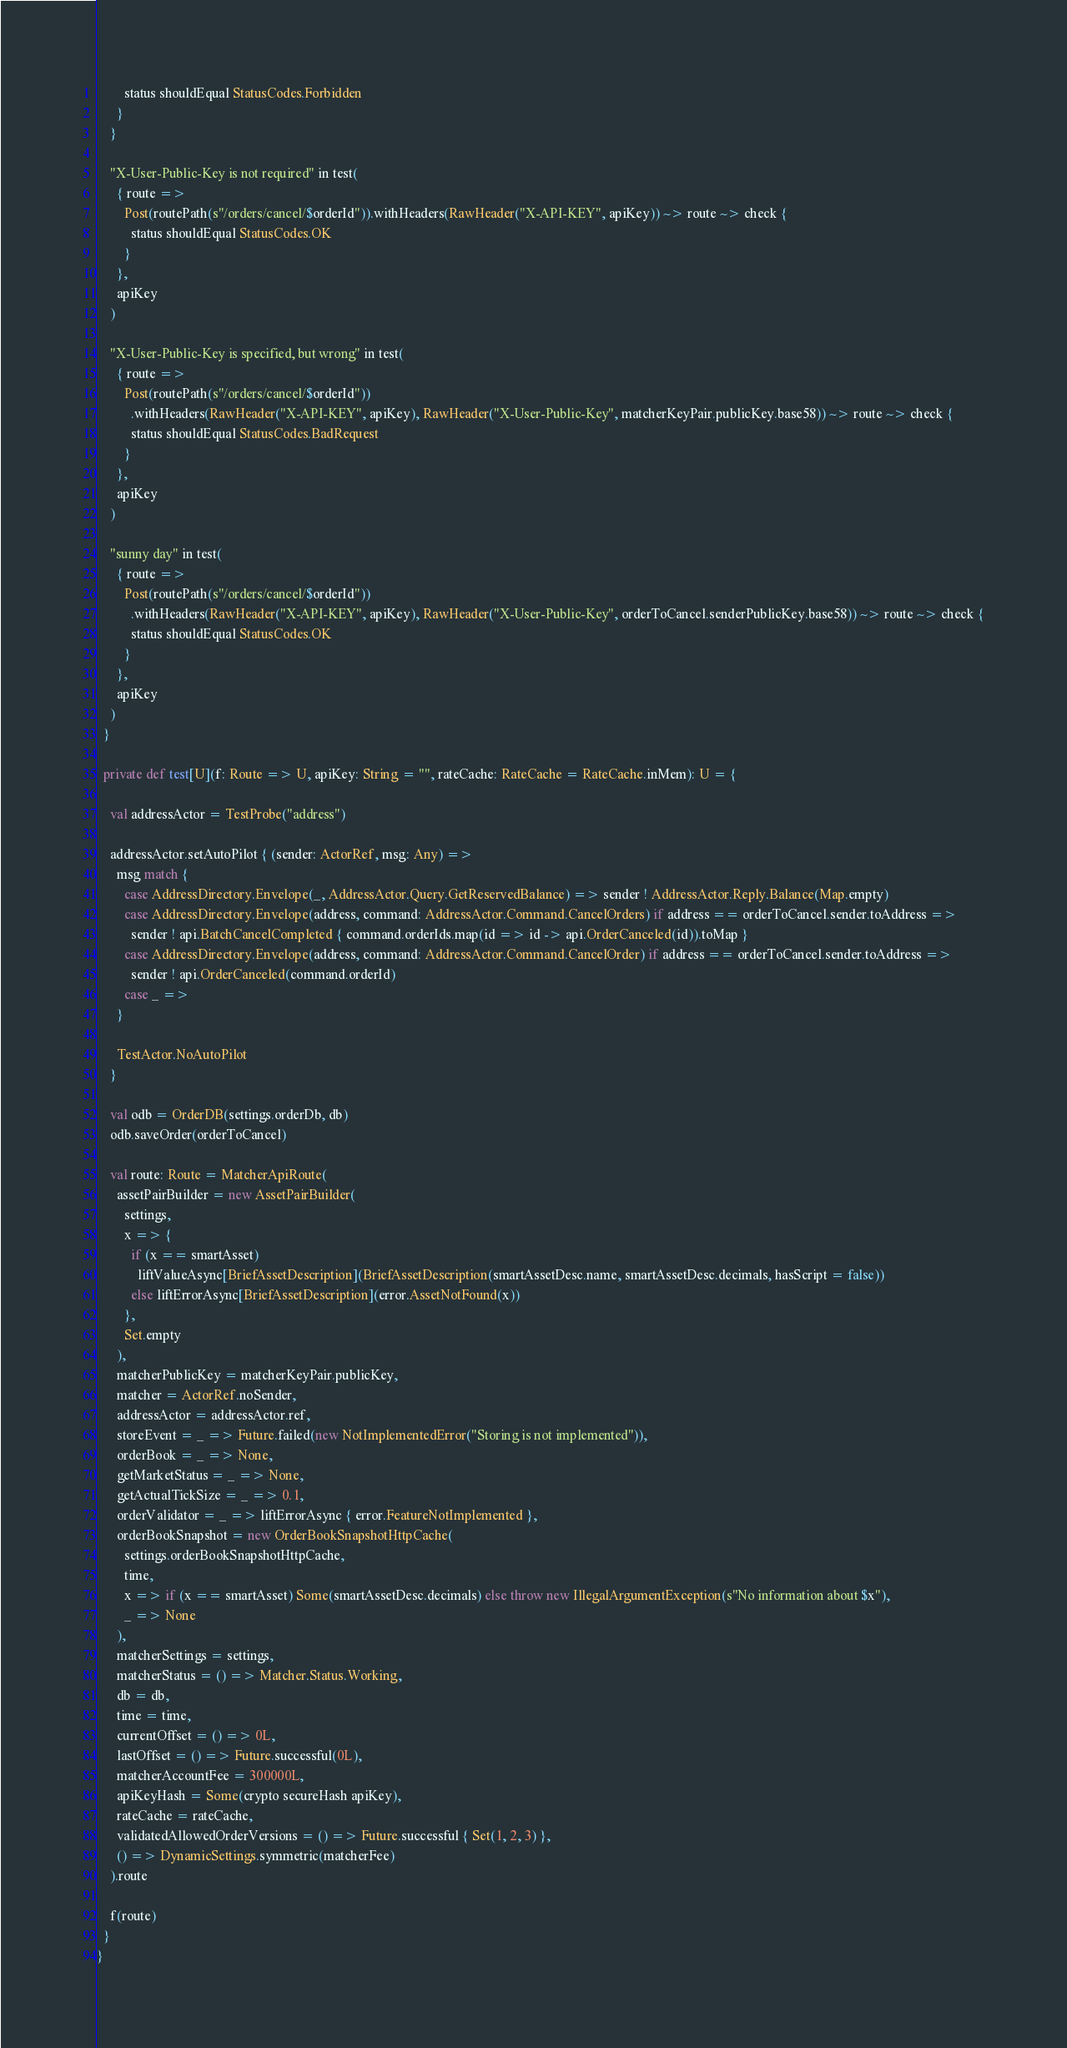Convert code to text. <code><loc_0><loc_0><loc_500><loc_500><_Scala_>        status shouldEqual StatusCodes.Forbidden
      }
    }

    "X-User-Public-Key is not required" in test(
      { route =>
        Post(routePath(s"/orders/cancel/$orderId")).withHeaders(RawHeader("X-API-KEY", apiKey)) ~> route ~> check {
          status shouldEqual StatusCodes.OK
        }
      },
      apiKey
    )

    "X-User-Public-Key is specified, but wrong" in test(
      { route =>
        Post(routePath(s"/orders/cancel/$orderId"))
          .withHeaders(RawHeader("X-API-KEY", apiKey), RawHeader("X-User-Public-Key", matcherKeyPair.publicKey.base58)) ~> route ~> check {
          status shouldEqual StatusCodes.BadRequest
        }
      },
      apiKey
    )

    "sunny day" in test(
      { route =>
        Post(routePath(s"/orders/cancel/$orderId"))
          .withHeaders(RawHeader("X-API-KEY", apiKey), RawHeader("X-User-Public-Key", orderToCancel.senderPublicKey.base58)) ~> route ~> check {
          status shouldEqual StatusCodes.OK
        }
      },
      apiKey
    )
  }

  private def test[U](f: Route => U, apiKey: String = "", rateCache: RateCache = RateCache.inMem): U = {

    val addressActor = TestProbe("address")

    addressActor.setAutoPilot { (sender: ActorRef, msg: Any) =>
      msg match {
        case AddressDirectory.Envelope(_, AddressActor.Query.GetReservedBalance) => sender ! AddressActor.Reply.Balance(Map.empty)
        case AddressDirectory.Envelope(address, command: AddressActor.Command.CancelOrders) if address == orderToCancel.sender.toAddress =>
          sender ! api.BatchCancelCompleted { command.orderIds.map(id => id -> api.OrderCanceled(id)).toMap }
        case AddressDirectory.Envelope(address, command: AddressActor.Command.CancelOrder) if address == orderToCancel.sender.toAddress =>
          sender ! api.OrderCanceled(command.orderId)
        case _ =>
      }

      TestActor.NoAutoPilot
    }

    val odb = OrderDB(settings.orderDb, db)
    odb.saveOrder(orderToCancel)

    val route: Route = MatcherApiRoute(
      assetPairBuilder = new AssetPairBuilder(
        settings,
        x => {
          if (x == smartAsset)
            liftValueAsync[BriefAssetDescription](BriefAssetDescription(smartAssetDesc.name, smartAssetDesc.decimals, hasScript = false))
          else liftErrorAsync[BriefAssetDescription](error.AssetNotFound(x))
        },
        Set.empty
      ),
      matcherPublicKey = matcherKeyPair.publicKey,
      matcher = ActorRef.noSender,
      addressActor = addressActor.ref,
      storeEvent = _ => Future.failed(new NotImplementedError("Storing is not implemented")),
      orderBook = _ => None,
      getMarketStatus = _ => None,
      getActualTickSize = _ => 0.1,
      orderValidator = _ => liftErrorAsync { error.FeatureNotImplemented },
      orderBookSnapshot = new OrderBookSnapshotHttpCache(
        settings.orderBookSnapshotHttpCache,
        time,
        x => if (x == smartAsset) Some(smartAssetDesc.decimals) else throw new IllegalArgumentException(s"No information about $x"),
        _ => None
      ),
      matcherSettings = settings,
      matcherStatus = () => Matcher.Status.Working,
      db = db,
      time = time,
      currentOffset = () => 0L,
      lastOffset = () => Future.successful(0L),
      matcherAccountFee = 300000L,
      apiKeyHash = Some(crypto secureHash apiKey),
      rateCache = rateCache,
      validatedAllowedOrderVersions = () => Future.successful { Set(1, 2, 3) },
      () => DynamicSettings.symmetric(matcherFee)
    ).route

    f(route)
  }
}
</code> 